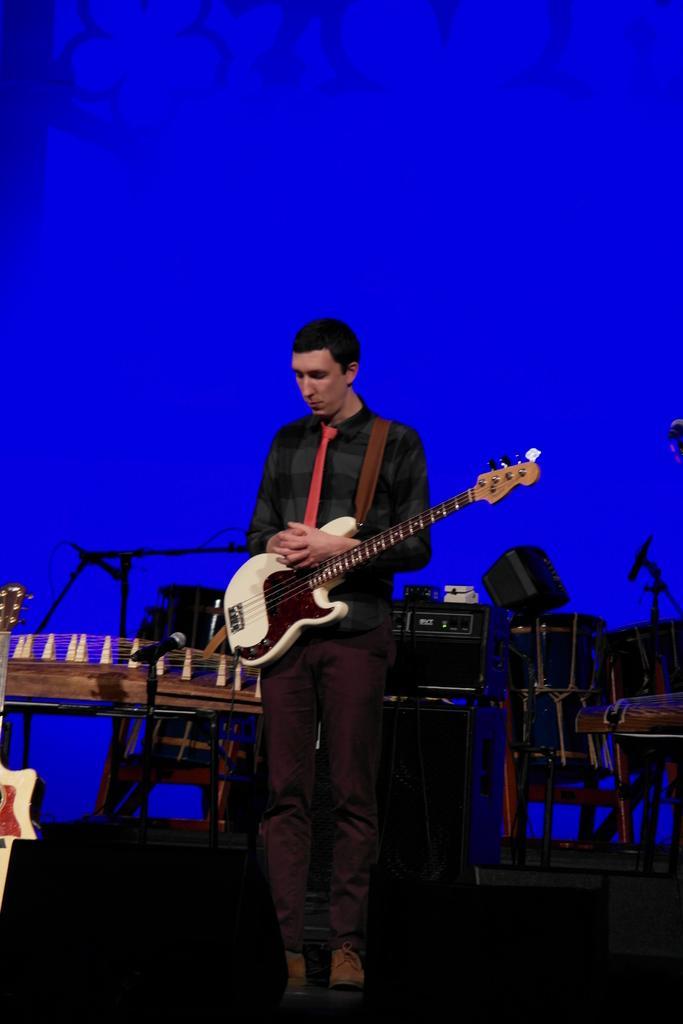Please provide a concise description of this image. In the image, a man is standing and holding the guitar,in the background there is a music system,there are also few other drums,there is a blue color light behind it. 